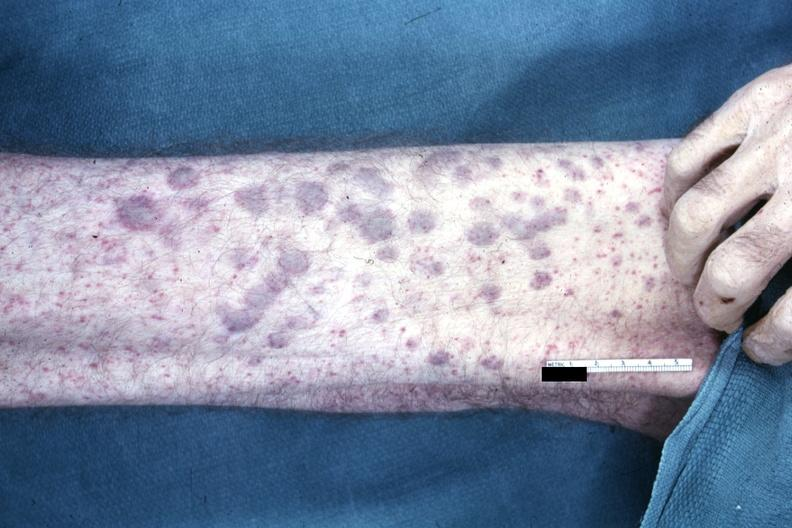does this image show?
Answer the question using a single word or phrase. Yes 